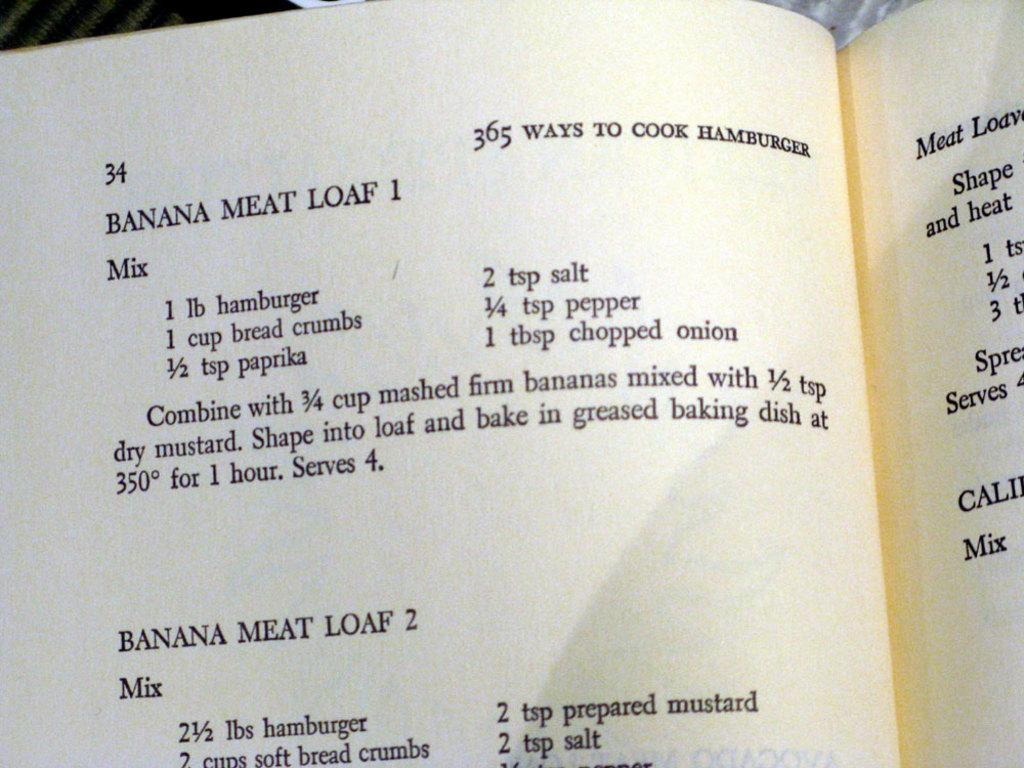<image>
Offer a succinct explanation of the picture presented. page 34 of the book 365 ways to cook hamburger. 